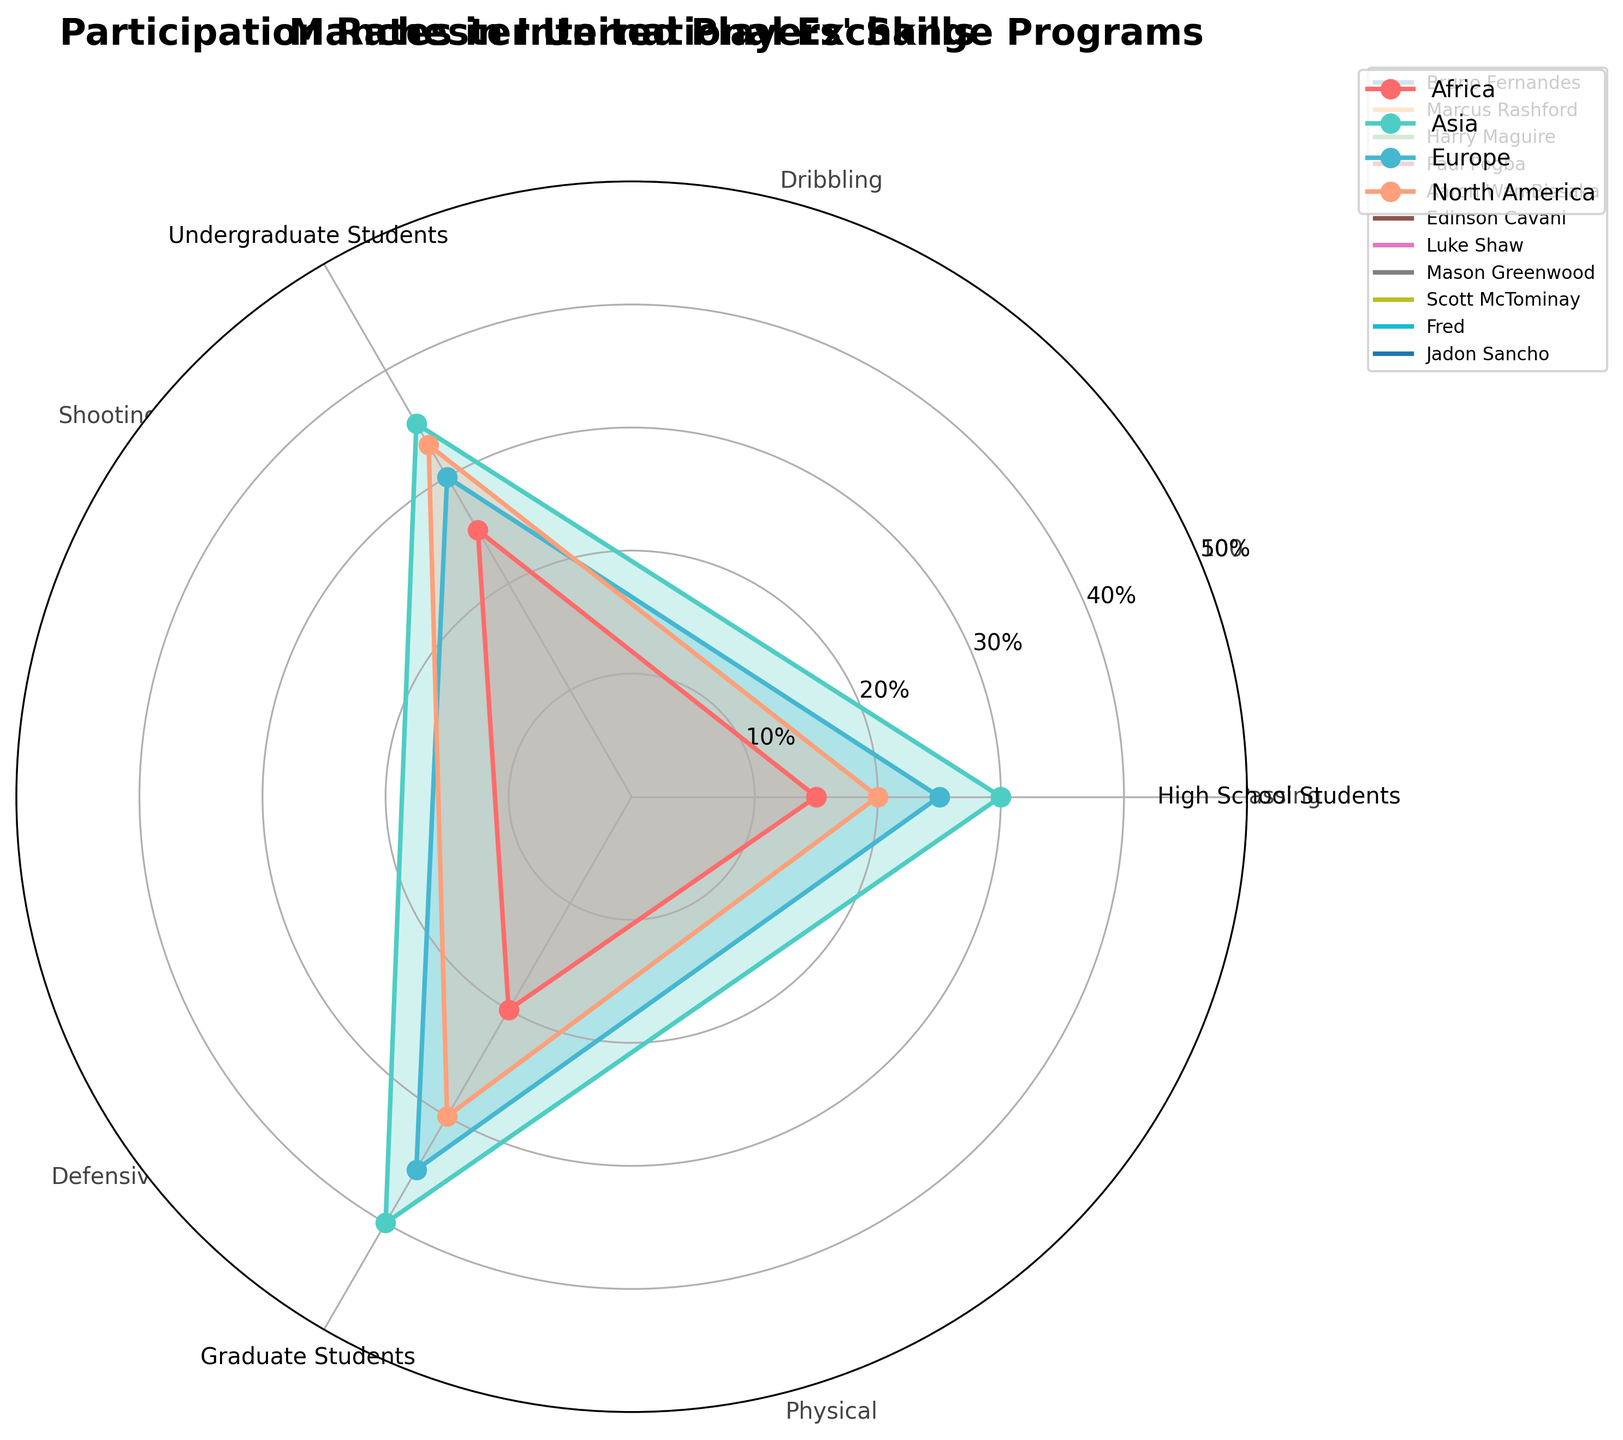What is the title of the radar chart? The title is clearly displayed at the top of the chart.
Answer: Participation Rates in International Exchange Programs Which continent has the highest participation rate for graduate students? The point for graduate students from Asia is at the top of the y-axis, higher than the other continents.
Answer: Asia Compare the participation rates of high school students between Europe and Africa. Which is higher? The blue line and the red line segments representing Europe and Africa align with the labels for high school students. The point for Europe is higher than that for Africa.
Answer: Europe What is the average participation rate of Undergraduate Students across all continents? Sum the participation rates for undergraduate students for each continent: (25 + 35 + 30 + 33) = 123. Divide by the number of continents: 123/4 = 30.75.
Answer: 30.75% Which continent shows the most balanced participation rates across all student categories? The continent with the points closest to forming a regular shape is Europe, with values of 25, 30, and 35.
Answer: Europe How much higher is the graduate student participation rate in Asia compared to North America? Subtract North America's graduate student rate from Asia's: 40 - 30 = 10.
Answer: 10% Between Asia and Africa, which has the greater variation in participation rates among the three student categories? Calculate the range for both: Asia (40-30) = 10, Africa (25-15) = 10. Both have the same variation.
Answer: Equal Which student group has the highest variation in participation rates between continents? Calculate the range for each category: High School Students (30-15) = 15, Undergraduate Students (35-25) = 10, Graduate Students (40-20) = 20.
Answer: Graduate Students How does the participation rate for undergraduate students in North America compare to that in Europe? The point for undergraduate students in North America is at the same level as Europe.
Answer: Equal 